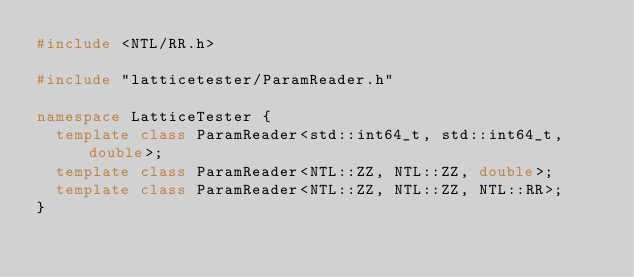Convert code to text. <code><loc_0><loc_0><loc_500><loc_500><_C++_>#include <NTL/RR.h>

#include "latticetester/ParamReader.h"

namespace LatticeTester {
  template class ParamReader<std::int64_t, std::int64_t, double>;
  template class ParamReader<NTL::ZZ, NTL::ZZ, double>;
  template class ParamReader<NTL::ZZ, NTL::ZZ, NTL::RR>;
}
</code> 